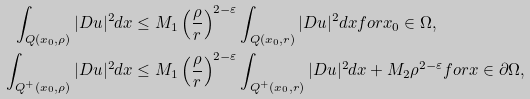<formula> <loc_0><loc_0><loc_500><loc_500>\int _ { Q ( x _ { 0 } , \rho ) } | D u | ^ { 2 } d x & \leq M _ { 1 } \left ( \frac { \rho } { r } \right ) ^ { 2 - \varepsilon } \int _ { Q ( x _ { 0 } , r ) } | D u | ^ { 2 } d x f o r x _ { 0 } \in \Omega , \\ \int _ { Q ^ { + } ( x _ { 0 } , \rho ) } | D u | ^ { 2 } d x & \leq M _ { 1 } \left ( \frac { \rho } { r } \right ) ^ { 2 - \varepsilon } \int _ { Q ^ { + } ( x _ { 0 } , r ) } | D u | ^ { 2 } d x + M _ { 2 } \rho ^ { 2 - \varepsilon } f o r x \in \partial \Omega ,</formula> 